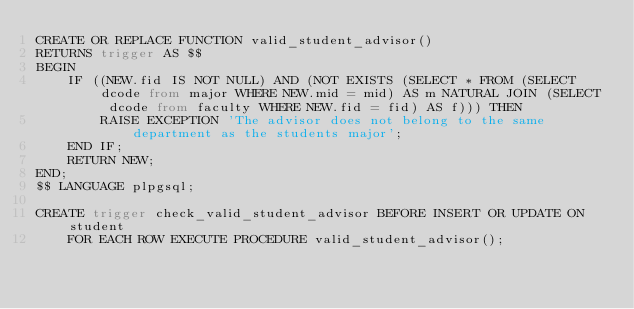<code> <loc_0><loc_0><loc_500><loc_500><_SQL_>CREATE OR REPLACE FUNCTION valid_student_advisor()
RETURNS trigger AS $$
BEGIN
    IF ((NEW.fid IS NOT NULL) AND (NOT EXISTS (SELECT * FROM (SELECT dcode from major WHERE NEW.mid = mid) AS m NATURAL JOIN (SELECT dcode from faculty WHERE NEW.fid = fid) AS f))) THEN
        RAISE EXCEPTION 'The advisor does not belong to the same department as the students major';
    END IF;
    RETURN NEW;
END;
$$ LANGUAGE plpgsql;

CREATE trigger check_valid_student_advisor BEFORE INSERT OR UPDATE ON student
    FOR EACH ROW EXECUTE PROCEDURE valid_student_advisor();</code> 